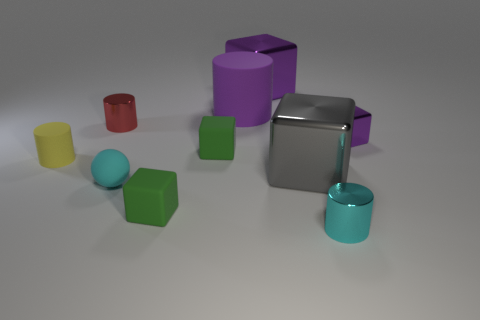Subtract all small red cylinders. How many cylinders are left? 3 Subtract 3 cubes. How many cubes are left? 2 Add 3 gray rubber objects. How many gray rubber objects exist? 3 Subtract all purple blocks. How many blocks are left? 3 Subtract 1 purple cubes. How many objects are left? 9 Subtract all cylinders. How many objects are left? 6 Subtract all purple cubes. Subtract all brown cylinders. How many cubes are left? 3 Subtract all green blocks. How many gray balls are left? 0 Subtract all big green spheres. Subtract all small red things. How many objects are left? 9 Add 5 large gray metal objects. How many large gray metal objects are left? 6 